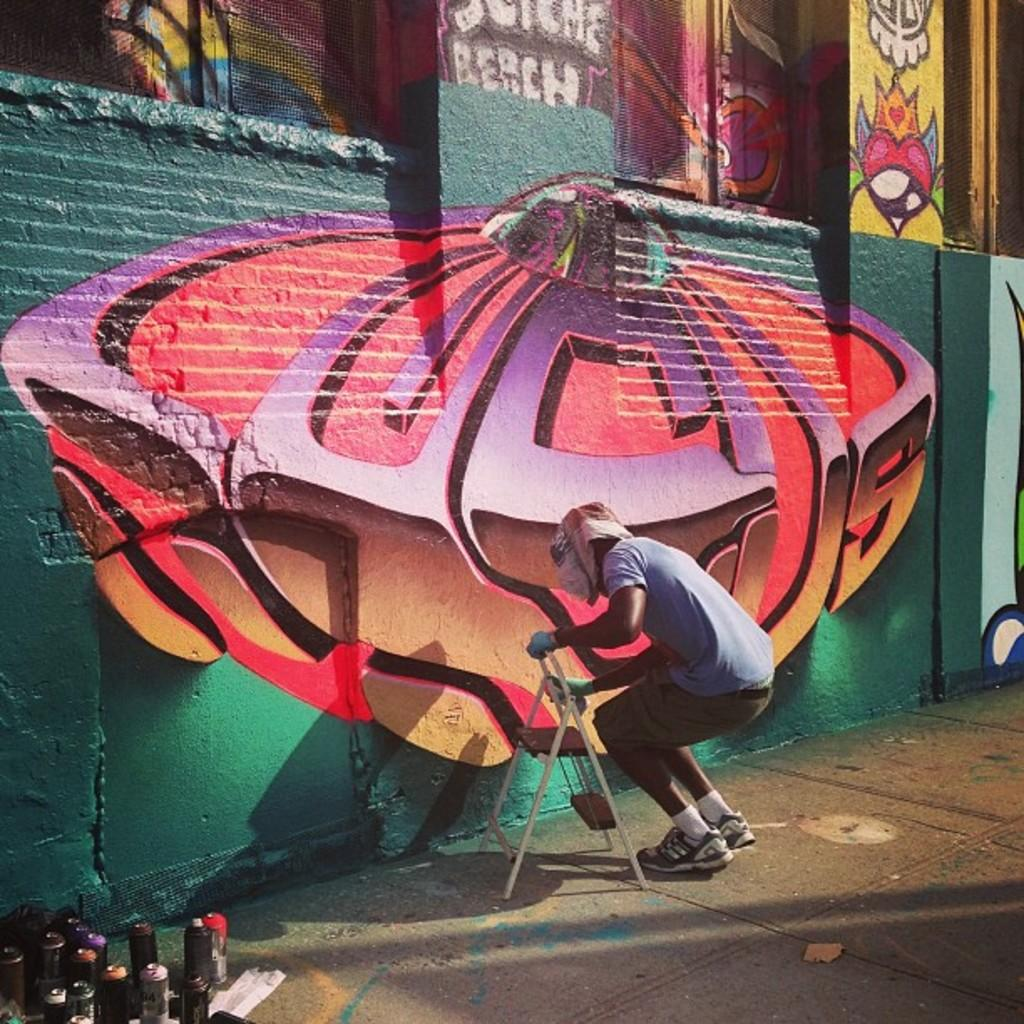What is the person in the image doing? The person is standing in the image and holding an object. Can you describe the object the person is holding? The details of the object are not mentioned in the facts, so we cannot describe it. What can be seen in the bottom left corner of the image? There are bottles in the bottom left corner of the image. What type of artwork is visible in the image? There is a graffiti painting on a wall in the image. What type of powder is being used to create harmony in the image? There is no mention of powder or harmony in the image, so we cannot answer this question. 